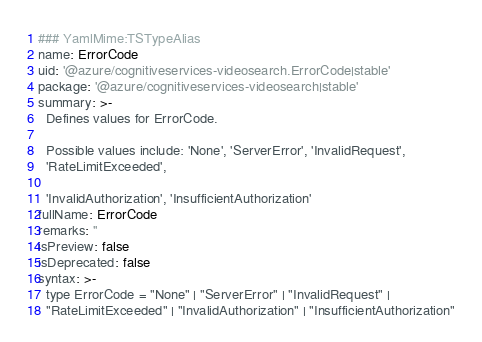Convert code to text. <code><loc_0><loc_0><loc_500><loc_500><_YAML_>### YamlMime:TSTypeAlias
name: ErrorCode
uid: '@azure/cognitiveservices-videosearch.ErrorCode|stable'
package: '@azure/cognitiveservices-videosearch|stable'
summary: >-
  Defines values for ErrorCode.

  Possible values include: 'None', 'ServerError', 'InvalidRequest',
  'RateLimitExceeded',

  'InvalidAuthorization', 'InsufficientAuthorization'
fullName: ErrorCode
remarks: ''
isPreview: false
isDeprecated: false
syntax: >-
  type ErrorCode = "None" | "ServerError" | "InvalidRequest" |
  "RateLimitExceeded" | "InvalidAuthorization" | "InsufficientAuthorization"
</code> 